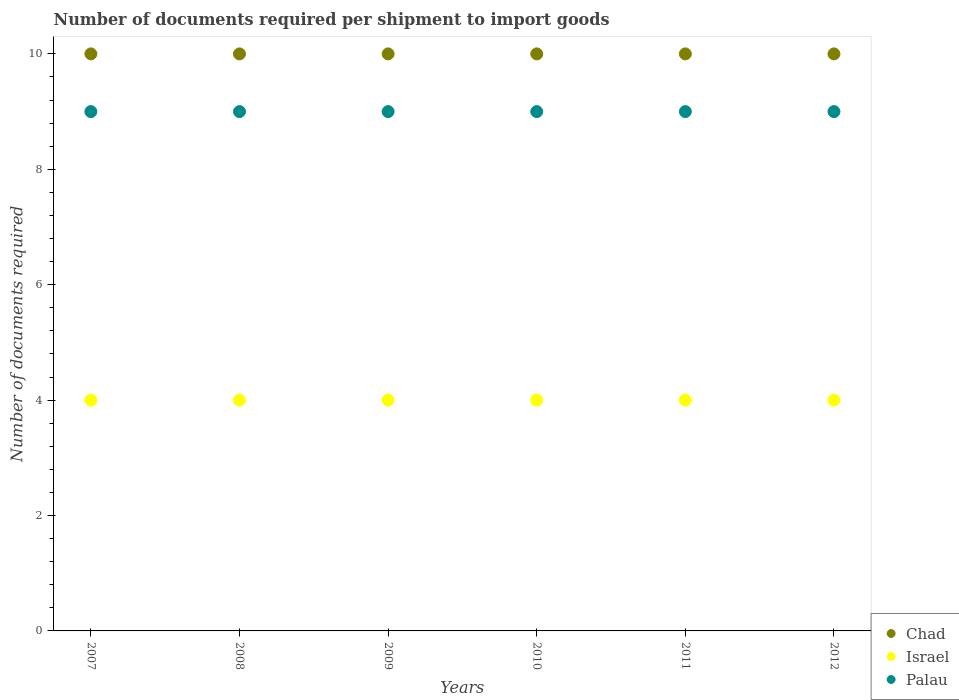How many different coloured dotlines are there?
Provide a short and direct response. 3. Is the number of dotlines equal to the number of legend labels?
Offer a very short reply. Yes. What is the number of documents required per shipment to import goods in Palau in 2010?
Your answer should be compact. 9. Across all years, what is the maximum number of documents required per shipment to import goods in Palau?
Your answer should be compact. 9. Across all years, what is the minimum number of documents required per shipment to import goods in Israel?
Make the answer very short. 4. In which year was the number of documents required per shipment to import goods in Chad maximum?
Your answer should be compact. 2007. In which year was the number of documents required per shipment to import goods in Palau minimum?
Offer a very short reply. 2007. What is the total number of documents required per shipment to import goods in Israel in the graph?
Your answer should be compact. 24. What is the difference between the number of documents required per shipment to import goods in Israel in 2007 and the number of documents required per shipment to import goods in Palau in 2012?
Your response must be concise. -5. What is the average number of documents required per shipment to import goods in Chad per year?
Your answer should be very brief. 10. In the year 2011, what is the difference between the number of documents required per shipment to import goods in Chad and number of documents required per shipment to import goods in Israel?
Keep it short and to the point. 6. What is the difference between the highest and the second highest number of documents required per shipment to import goods in Israel?
Give a very brief answer. 0. In how many years, is the number of documents required per shipment to import goods in Chad greater than the average number of documents required per shipment to import goods in Chad taken over all years?
Keep it short and to the point. 0. Is it the case that in every year, the sum of the number of documents required per shipment to import goods in Israel and number of documents required per shipment to import goods in Palau  is greater than the number of documents required per shipment to import goods in Chad?
Offer a very short reply. Yes. Is the number of documents required per shipment to import goods in Israel strictly less than the number of documents required per shipment to import goods in Chad over the years?
Give a very brief answer. Yes. Are the values on the major ticks of Y-axis written in scientific E-notation?
Make the answer very short. No. How many legend labels are there?
Keep it short and to the point. 3. How are the legend labels stacked?
Provide a short and direct response. Vertical. What is the title of the graph?
Your answer should be compact. Number of documents required per shipment to import goods. Does "Guam" appear as one of the legend labels in the graph?
Keep it short and to the point. No. What is the label or title of the Y-axis?
Your response must be concise. Number of documents required. What is the Number of documents required of Chad in 2007?
Ensure brevity in your answer.  10. What is the Number of documents required in Chad in 2008?
Provide a short and direct response. 10. What is the Number of documents required in Chad in 2009?
Provide a succinct answer. 10. What is the Number of documents required of Palau in 2009?
Offer a very short reply. 9. What is the Number of documents required of Chad in 2010?
Your answer should be very brief. 10. What is the Number of documents required in Israel in 2011?
Provide a short and direct response. 4. What is the Number of documents required of Palau in 2012?
Keep it short and to the point. 9. Across all years, what is the maximum Number of documents required in Palau?
Your response must be concise. 9. Across all years, what is the minimum Number of documents required of Israel?
Your response must be concise. 4. What is the total Number of documents required in Chad in the graph?
Ensure brevity in your answer.  60. What is the total Number of documents required of Israel in the graph?
Offer a terse response. 24. What is the difference between the Number of documents required of Chad in 2007 and that in 2008?
Offer a very short reply. 0. What is the difference between the Number of documents required of Palau in 2007 and that in 2008?
Ensure brevity in your answer.  0. What is the difference between the Number of documents required of Palau in 2007 and that in 2009?
Provide a short and direct response. 0. What is the difference between the Number of documents required in Israel in 2007 and that in 2011?
Offer a terse response. 0. What is the difference between the Number of documents required of Chad in 2007 and that in 2012?
Your answer should be compact. 0. What is the difference between the Number of documents required in Palau in 2007 and that in 2012?
Ensure brevity in your answer.  0. What is the difference between the Number of documents required in Palau in 2008 and that in 2009?
Offer a terse response. 0. What is the difference between the Number of documents required of Palau in 2008 and that in 2010?
Your answer should be very brief. 0. What is the difference between the Number of documents required in Chad in 2008 and that in 2011?
Offer a very short reply. 0. What is the difference between the Number of documents required in Israel in 2008 and that in 2011?
Give a very brief answer. 0. What is the difference between the Number of documents required of Palau in 2008 and that in 2011?
Make the answer very short. 0. What is the difference between the Number of documents required in Chad in 2008 and that in 2012?
Provide a short and direct response. 0. What is the difference between the Number of documents required of Israel in 2008 and that in 2012?
Offer a terse response. 0. What is the difference between the Number of documents required of Palau in 2009 and that in 2011?
Your answer should be compact. 0. What is the difference between the Number of documents required in Chad in 2009 and that in 2012?
Your response must be concise. 0. What is the difference between the Number of documents required in Israel in 2009 and that in 2012?
Provide a short and direct response. 0. What is the difference between the Number of documents required of Chad in 2010 and that in 2011?
Provide a short and direct response. 0. What is the difference between the Number of documents required of Israel in 2010 and that in 2011?
Give a very brief answer. 0. What is the difference between the Number of documents required of Palau in 2010 and that in 2011?
Ensure brevity in your answer.  0. What is the difference between the Number of documents required of Chad in 2010 and that in 2012?
Offer a terse response. 0. What is the difference between the Number of documents required of Israel in 2010 and that in 2012?
Ensure brevity in your answer.  0. What is the difference between the Number of documents required in Palau in 2010 and that in 2012?
Offer a very short reply. 0. What is the difference between the Number of documents required of Chad in 2007 and the Number of documents required of Palau in 2010?
Your response must be concise. 1. What is the difference between the Number of documents required in Chad in 2007 and the Number of documents required in Palau in 2012?
Your response must be concise. 1. What is the difference between the Number of documents required of Israel in 2007 and the Number of documents required of Palau in 2012?
Your response must be concise. -5. What is the difference between the Number of documents required in Chad in 2008 and the Number of documents required in Palau in 2009?
Keep it short and to the point. 1. What is the difference between the Number of documents required in Israel in 2008 and the Number of documents required in Palau in 2009?
Provide a succinct answer. -5. What is the difference between the Number of documents required of Chad in 2008 and the Number of documents required of Palau in 2010?
Offer a very short reply. 1. What is the difference between the Number of documents required of Chad in 2008 and the Number of documents required of Palau in 2011?
Your answer should be very brief. 1. What is the difference between the Number of documents required in Israel in 2008 and the Number of documents required in Palau in 2011?
Offer a very short reply. -5. What is the difference between the Number of documents required in Israel in 2008 and the Number of documents required in Palau in 2012?
Provide a short and direct response. -5. What is the difference between the Number of documents required in Chad in 2009 and the Number of documents required in Israel in 2012?
Give a very brief answer. 6. What is the difference between the Number of documents required in Israel in 2009 and the Number of documents required in Palau in 2012?
Make the answer very short. -5. What is the difference between the Number of documents required of Chad in 2010 and the Number of documents required of Israel in 2011?
Ensure brevity in your answer.  6. What is the difference between the Number of documents required in Israel in 2010 and the Number of documents required in Palau in 2011?
Provide a succinct answer. -5. What is the difference between the Number of documents required in Chad in 2010 and the Number of documents required in Israel in 2012?
Your response must be concise. 6. What is the difference between the Number of documents required of Israel in 2010 and the Number of documents required of Palau in 2012?
Keep it short and to the point. -5. What is the difference between the Number of documents required of Israel in 2011 and the Number of documents required of Palau in 2012?
Make the answer very short. -5. What is the average Number of documents required of Palau per year?
Offer a terse response. 9. In the year 2007, what is the difference between the Number of documents required in Chad and Number of documents required in Israel?
Your answer should be compact. 6. In the year 2008, what is the difference between the Number of documents required in Chad and Number of documents required in Israel?
Provide a succinct answer. 6. In the year 2008, what is the difference between the Number of documents required in Chad and Number of documents required in Palau?
Your response must be concise. 1. In the year 2009, what is the difference between the Number of documents required of Chad and Number of documents required of Palau?
Provide a succinct answer. 1. In the year 2009, what is the difference between the Number of documents required of Israel and Number of documents required of Palau?
Offer a very short reply. -5. In the year 2010, what is the difference between the Number of documents required of Israel and Number of documents required of Palau?
Offer a very short reply. -5. In the year 2011, what is the difference between the Number of documents required in Chad and Number of documents required in Palau?
Ensure brevity in your answer.  1. In the year 2011, what is the difference between the Number of documents required of Israel and Number of documents required of Palau?
Provide a succinct answer. -5. In the year 2012, what is the difference between the Number of documents required in Chad and Number of documents required in Israel?
Your answer should be very brief. 6. In the year 2012, what is the difference between the Number of documents required of Chad and Number of documents required of Palau?
Offer a very short reply. 1. What is the ratio of the Number of documents required in Palau in 2007 to that in 2008?
Offer a terse response. 1. What is the ratio of the Number of documents required of Palau in 2007 to that in 2009?
Make the answer very short. 1. What is the ratio of the Number of documents required in Israel in 2007 to that in 2010?
Keep it short and to the point. 1. What is the ratio of the Number of documents required of Chad in 2007 to that in 2011?
Ensure brevity in your answer.  1. What is the ratio of the Number of documents required in Israel in 2007 to that in 2011?
Provide a succinct answer. 1. What is the ratio of the Number of documents required of Chad in 2007 to that in 2012?
Your answer should be compact. 1. What is the ratio of the Number of documents required in Israel in 2007 to that in 2012?
Your answer should be compact. 1. What is the ratio of the Number of documents required in Chad in 2008 to that in 2009?
Your answer should be very brief. 1. What is the ratio of the Number of documents required of Israel in 2008 to that in 2009?
Offer a very short reply. 1. What is the ratio of the Number of documents required in Palau in 2008 to that in 2009?
Your answer should be very brief. 1. What is the ratio of the Number of documents required of Palau in 2008 to that in 2010?
Ensure brevity in your answer.  1. What is the ratio of the Number of documents required in Chad in 2008 to that in 2011?
Provide a succinct answer. 1. What is the ratio of the Number of documents required in Chad in 2008 to that in 2012?
Ensure brevity in your answer.  1. What is the ratio of the Number of documents required in Palau in 2008 to that in 2012?
Provide a short and direct response. 1. What is the ratio of the Number of documents required of Israel in 2009 to that in 2010?
Make the answer very short. 1. What is the ratio of the Number of documents required of Palau in 2009 to that in 2010?
Keep it short and to the point. 1. What is the ratio of the Number of documents required of Chad in 2009 to that in 2011?
Ensure brevity in your answer.  1. What is the ratio of the Number of documents required of Palau in 2009 to that in 2011?
Offer a terse response. 1. What is the ratio of the Number of documents required of Palau in 2009 to that in 2012?
Provide a short and direct response. 1. What is the ratio of the Number of documents required in Chad in 2010 to that in 2011?
Keep it short and to the point. 1. What is the ratio of the Number of documents required of Israel in 2010 to that in 2011?
Your answer should be very brief. 1. What is the ratio of the Number of documents required of Palau in 2010 to that in 2011?
Ensure brevity in your answer.  1. What is the ratio of the Number of documents required in Israel in 2010 to that in 2012?
Offer a terse response. 1. What is the ratio of the Number of documents required in Chad in 2011 to that in 2012?
Offer a very short reply. 1. What is the ratio of the Number of documents required in Palau in 2011 to that in 2012?
Give a very brief answer. 1. What is the difference between the highest and the second highest Number of documents required in Chad?
Provide a short and direct response. 0. What is the difference between the highest and the second highest Number of documents required in Palau?
Make the answer very short. 0. What is the difference between the highest and the lowest Number of documents required of Israel?
Provide a succinct answer. 0. 